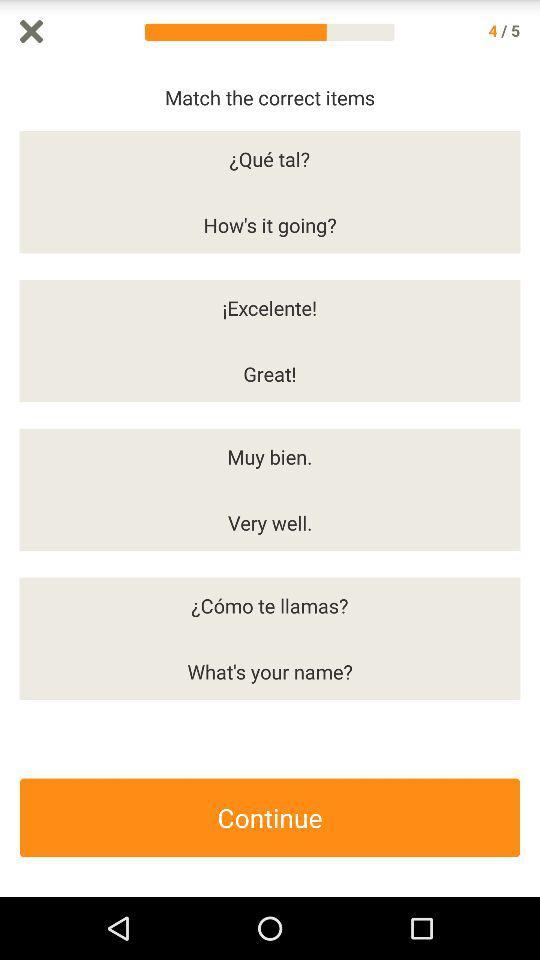How many questions in total are there? There are 5 questions in total. 